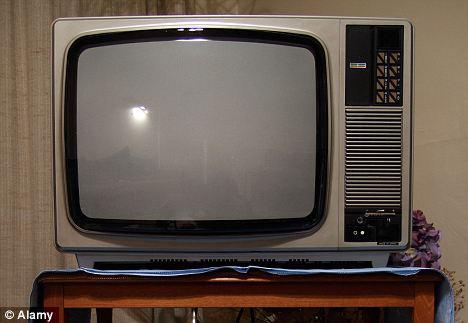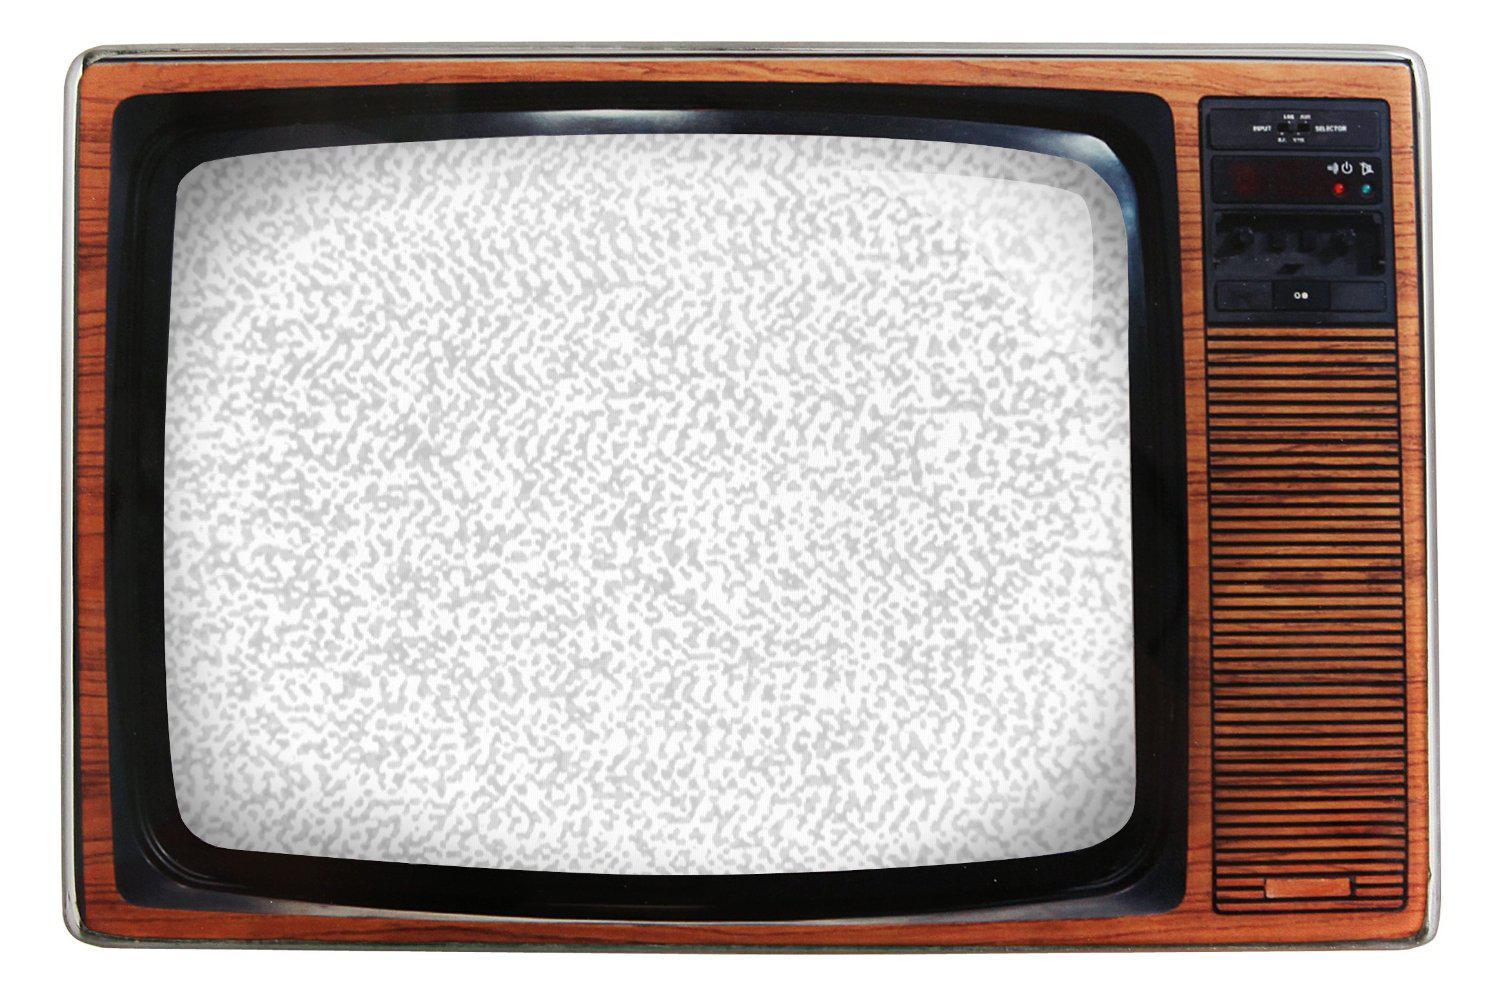The first image is the image on the left, the second image is the image on the right. Analyze the images presented: Is the assertion "There are at least two round knobs on each television." valid? Answer yes or no. No. 